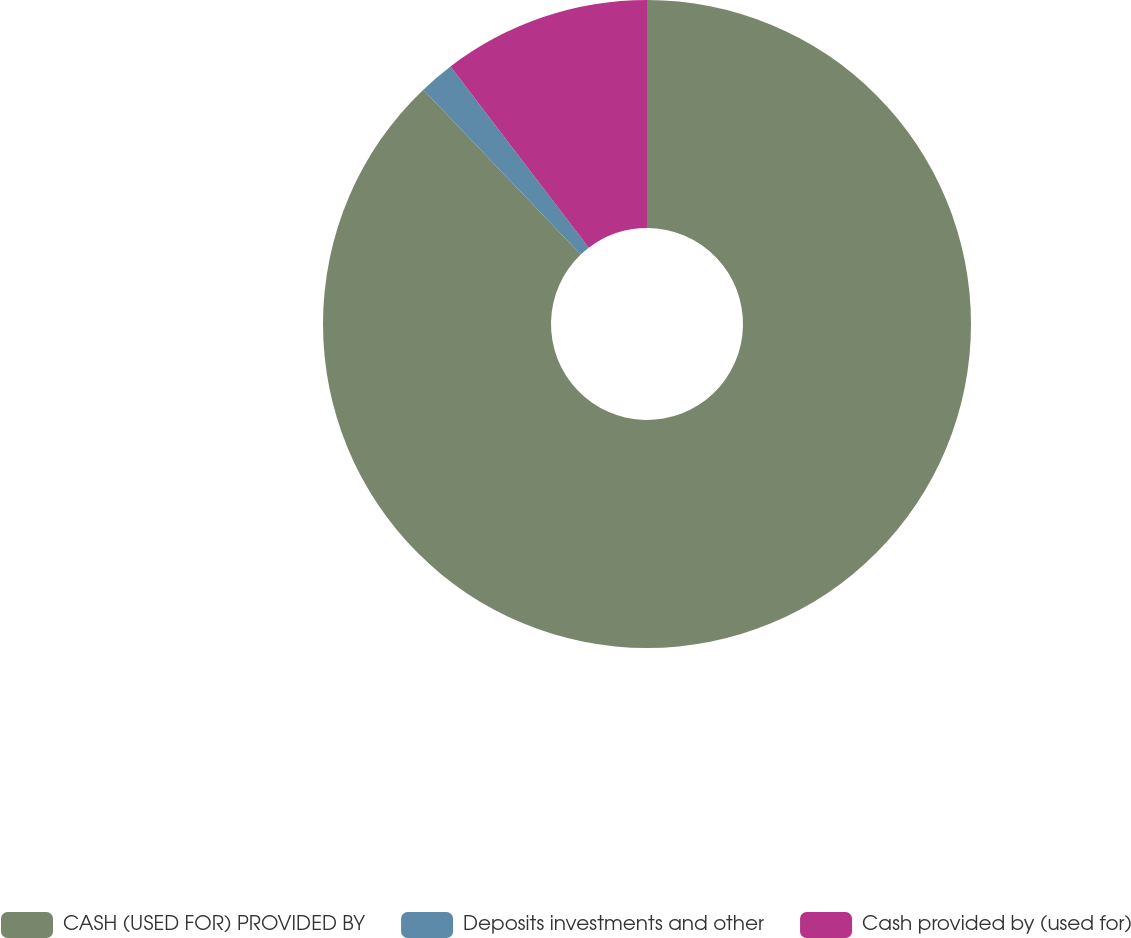<chart> <loc_0><loc_0><loc_500><loc_500><pie_chart><fcel>CASH (USED FOR) PROVIDED BY<fcel>Deposits investments and other<fcel>Cash provided by (used for)<nl><fcel>87.87%<fcel>1.76%<fcel>10.37%<nl></chart> 